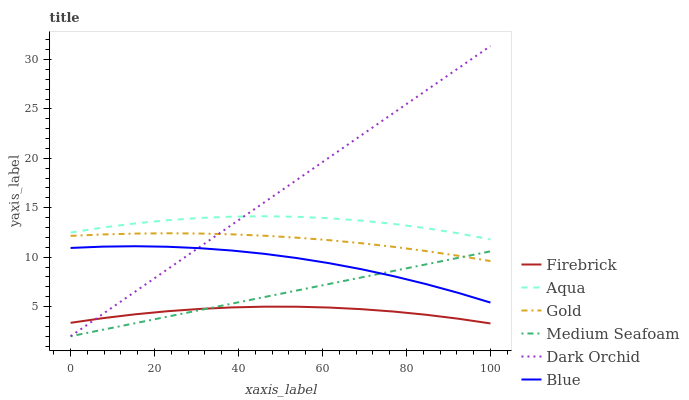Does Firebrick have the minimum area under the curve?
Answer yes or no. Yes. Does Dark Orchid have the maximum area under the curve?
Answer yes or no. Yes. Does Gold have the minimum area under the curve?
Answer yes or no. No. Does Gold have the maximum area under the curve?
Answer yes or no. No. Is Dark Orchid the smoothest?
Answer yes or no. Yes. Is Aqua the roughest?
Answer yes or no. Yes. Is Gold the smoothest?
Answer yes or no. No. Is Gold the roughest?
Answer yes or no. No. Does Dark Orchid have the lowest value?
Answer yes or no. Yes. Does Gold have the lowest value?
Answer yes or no. No. Does Dark Orchid have the highest value?
Answer yes or no. Yes. Does Gold have the highest value?
Answer yes or no. No. Is Medium Seafoam less than Aqua?
Answer yes or no. Yes. Is Aqua greater than Gold?
Answer yes or no. Yes. Does Dark Orchid intersect Aqua?
Answer yes or no. Yes. Is Dark Orchid less than Aqua?
Answer yes or no. No. Is Dark Orchid greater than Aqua?
Answer yes or no. No. Does Medium Seafoam intersect Aqua?
Answer yes or no. No. 